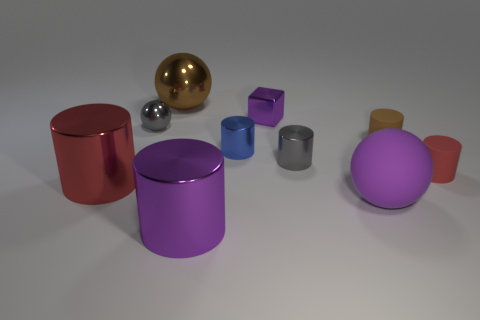Subtract all brown rubber cylinders. How many cylinders are left? 5 Subtract all purple cylinders. How many cylinders are left? 5 Subtract all blue cylinders. Subtract all red cubes. How many cylinders are left? 5 Subtract all cylinders. How many objects are left? 4 Subtract 0 cyan balls. How many objects are left? 10 Subtract all tiny gray things. Subtract all blue objects. How many objects are left? 7 Add 2 large metal spheres. How many large metal spheres are left? 3 Add 1 purple cylinders. How many purple cylinders exist? 2 